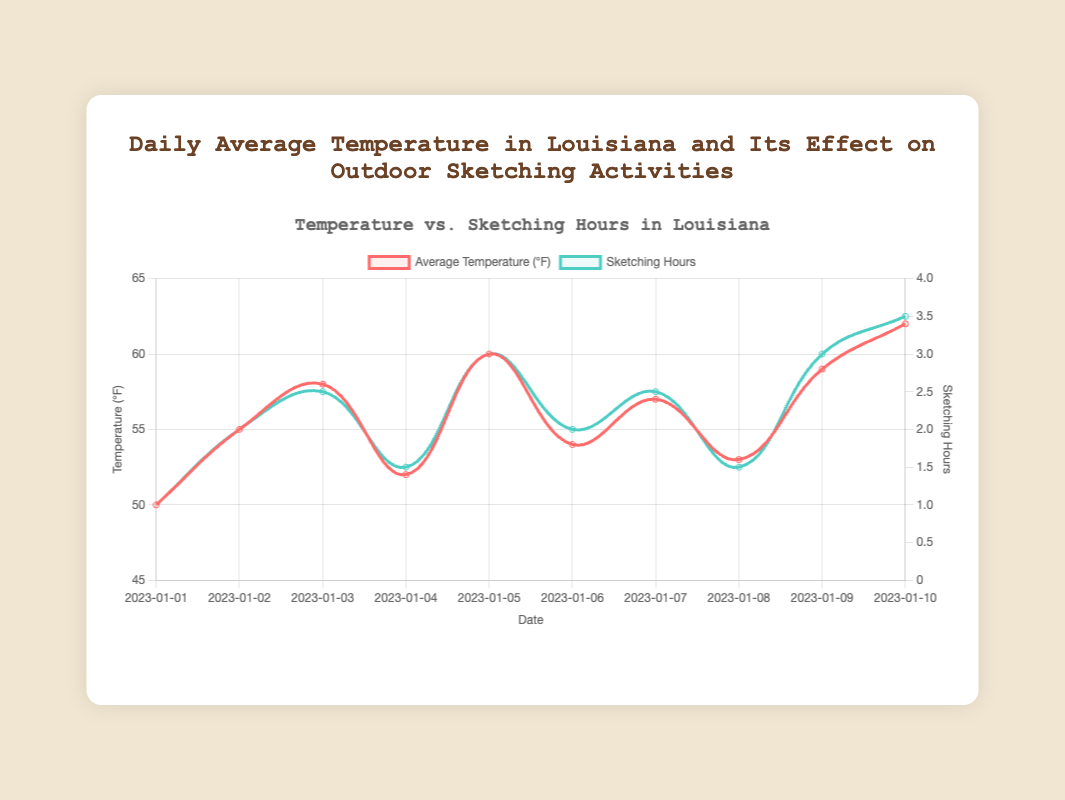What's the range of temperatures observed over the period? The range is calculated by subtracting the lowest temperature from the highest temperature. The lowest temperature is 50°F (on January 1), and the highest temperature is 62°F (on January 10). So, 62°F - 50°F = 12°F
Answer: 12°F On which date was the highest number of sketching hours recorded and what were the conditions? The maximum sketching hours of 3.5 hours were recorded on January 10, and the conditions were sunny. This can be seen from the peak of the green line on January 10 and the tooltip information showing sunny conditions.
Answer: January 10, sunny Compare the sketching hours recorded in Baton Rouge on January 2 and January 9. Which day had more sketching hours and by how much? On January 2, Baton Rouge had 2 sketching hours and on January 9, it had 3 sketching hours. The difference is 3 - 2 = 1 hour, with January 9 having more sketching hours.
Answer: January 9, 1 hour What is the average sketching hours across all the dates? Sum up all sketching hours (1 + 2 + 2.5 + 1.5 + 3 + 2 + 2.5 + 1.5 + 3 + 3.5 = 22.5 hours) and divide by the number of dates (10). The average is 22.5 / 10 = 2.25 hours
Answer: 2.25 hours How many days had temperatures in the range of 55°F to 60°F? Looking at the temperature line, dates with temperatures in this range are January 2 (55°F), January 3 (58°F), January 6 (54°F, not in the range), January 7 (57°F), January 9 (59°F). So, there are 4 days.
Answer: 4 days Are there any dates where both the temperature and sketching hours were below average? First calculate the average temperature  (50 + 55 + 58 + 52 + 60 + 54 + 57 + 53 + 59 + 62 = 560, 560 / 10 = 56°F) and sketching hours (previously calculated as 2.25 hours). Then check each date. January 1 has 50°F (below 56°F) and 1 hour (below 2.25 hours). Hence, January 1 meets both criteria.
Answer: January 1 Which day had the steepest increase in sketching hours compared to the previous day? Calculate the increase in sketching hours for each consecutive day. The difference is highest between January 1 (1 hour) and January 2 (2 hours), which is an increase of 1 hour.
Answer: January 2 